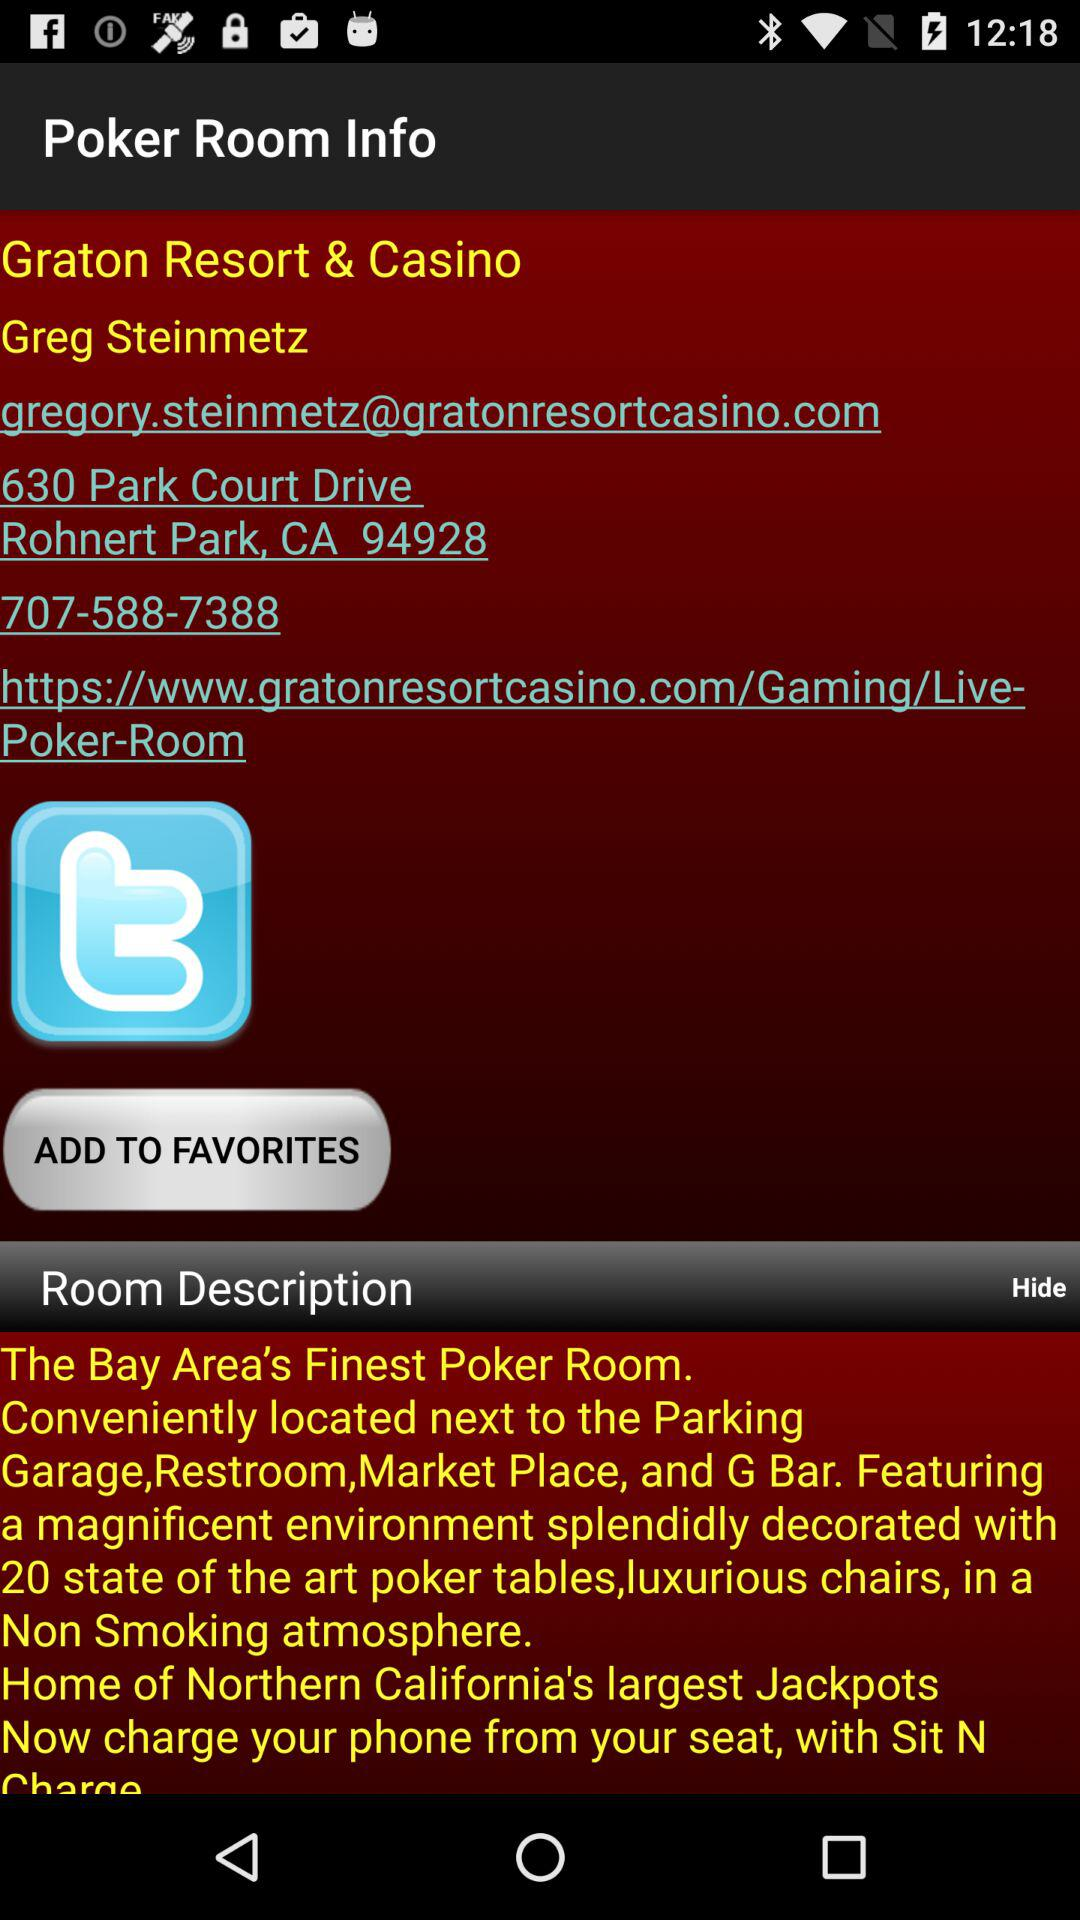Where is the poker room? The poker room is at 630 Park Court Drive, Rohnert Park, CA 94928. 